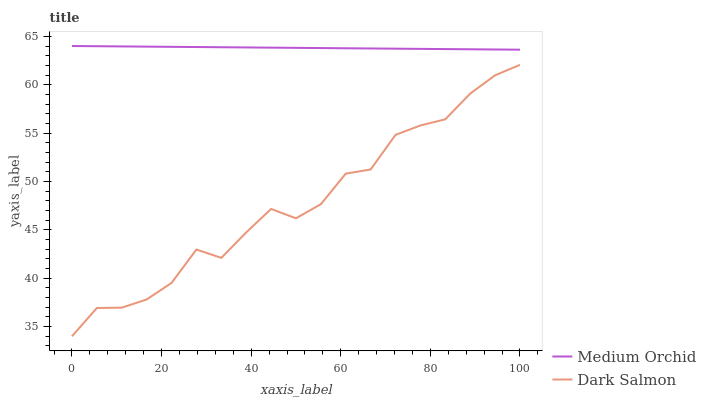Does Dark Salmon have the minimum area under the curve?
Answer yes or no. Yes. Does Medium Orchid have the maximum area under the curve?
Answer yes or no. Yes. Does Dark Salmon have the maximum area under the curve?
Answer yes or no. No. Is Medium Orchid the smoothest?
Answer yes or no. Yes. Is Dark Salmon the roughest?
Answer yes or no. Yes. Is Dark Salmon the smoothest?
Answer yes or no. No. Does Dark Salmon have the lowest value?
Answer yes or no. Yes. Does Medium Orchid have the highest value?
Answer yes or no. Yes. Does Dark Salmon have the highest value?
Answer yes or no. No. Is Dark Salmon less than Medium Orchid?
Answer yes or no. Yes. Is Medium Orchid greater than Dark Salmon?
Answer yes or no. Yes. Does Dark Salmon intersect Medium Orchid?
Answer yes or no. No. 